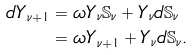<formula> <loc_0><loc_0><loc_500><loc_500>d Y _ { \nu + 1 } & = \omega Y _ { \nu } \mathbb { S } _ { \nu } + Y _ { \nu } d \mathbb { S } _ { \nu } \\ \, & = \omega Y _ { \nu + 1 } + Y _ { \nu } d \mathbb { S } _ { \nu } .</formula> 